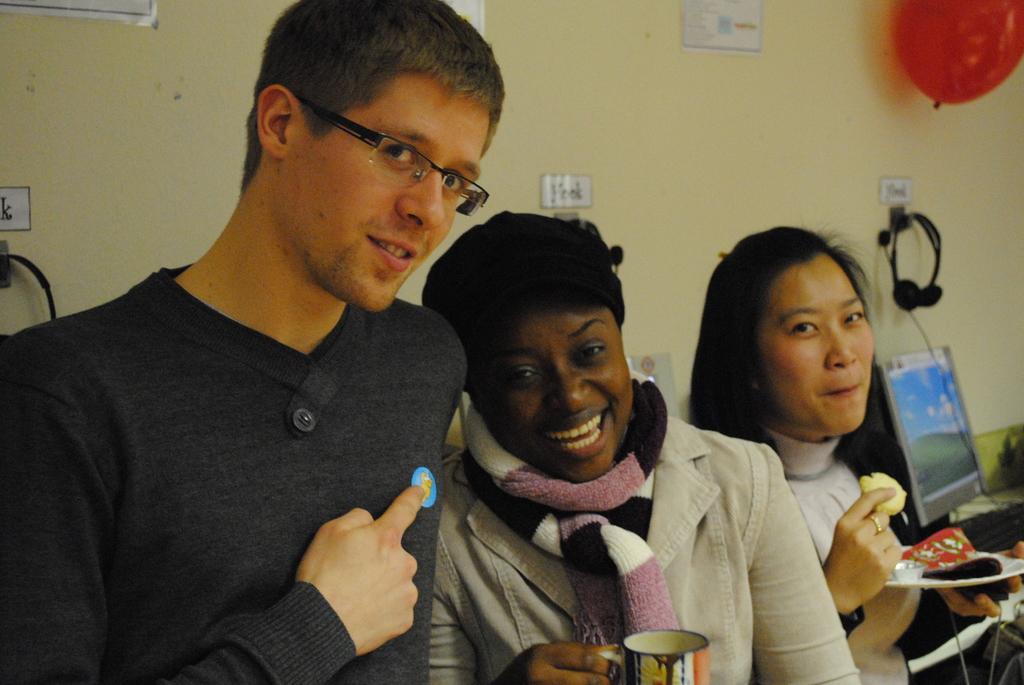Could you give a brief overview of what you see in this image? On the left side a man is pointing his finger, he wore black color t-shirt, spectacles. In the middle a woman is smiling and also holding the cup in her right hand, on the right side a woman is eating the food items, there is a desk top at here and at the top there is a balloon in red color. 